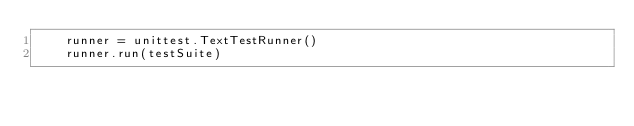<code> <loc_0><loc_0><loc_500><loc_500><_Python_>    runner = unittest.TextTestRunner()
    runner.run(testSuite)
</code> 